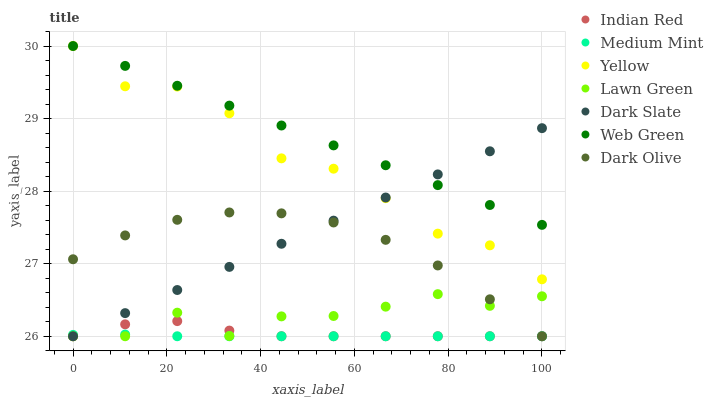Does Medium Mint have the minimum area under the curve?
Answer yes or no. Yes. Does Web Green have the maximum area under the curve?
Answer yes or no. Yes. Does Lawn Green have the minimum area under the curve?
Answer yes or no. No. Does Lawn Green have the maximum area under the curve?
Answer yes or no. No. Is Dark Slate the smoothest?
Answer yes or no. Yes. Is Yellow the roughest?
Answer yes or no. Yes. Is Lawn Green the smoothest?
Answer yes or no. No. Is Lawn Green the roughest?
Answer yes or no. No. Does Medium Mint have the lowest value?
Answer yes or no. Yes. Does Web Green have the lowest value?
Answer yes or no. No. Does Yellow have the highest value?
Answer yes or no. Yes. Does Lawn Green have the highest value?
Answer yes or no. No. Is Lawn Green less than Yellow?
Answer yes or no. Yes. Is Web Green greater than Dark Olive?
Answer yes or no. Yes. Does Indian Red intersect Lawn Green?
Answer yes or no. Yes. Is Indian Red less than Lawn Green?
Answer yes or no. No. Is Indian Red greater than Lawn Green?
Answer yes or no. No. Does Lawn Green intersect Yellow?
Answer yes or no. No. 